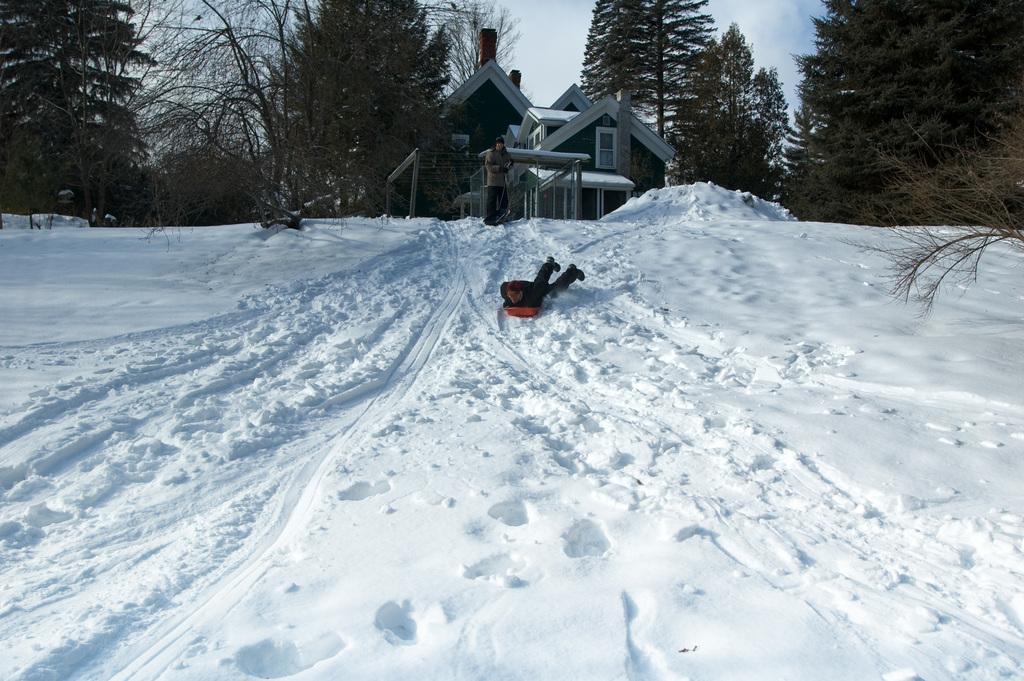In one or two sentences, can you explain what this image depicts? Here we can see a person lying on a board and skating on the snow. In the background we can see a person standing on the snow,house,windows,trees and sky. 